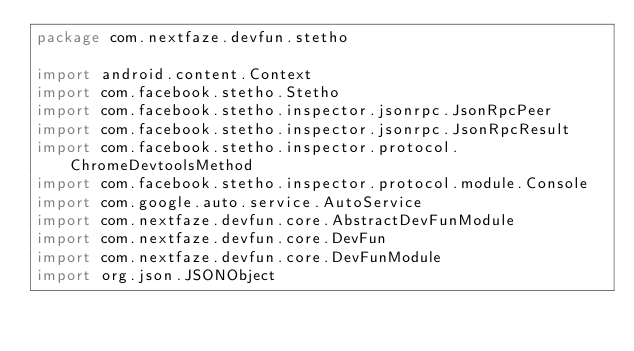Convert code to text. <code><loc_0><loc_0><loc_500><loc_500><_Kotlin_>package com.nextfaze.devfun.stetho

import android.content.Context
import com.facebook.stetho.Stetho
import com.facebook.stetho.inspector.jsonrpc.JsonRpcPeer
import com.facebook.stetho.inspector.jsonrpc.JsonRpcResult
import com.facebook.stetho.inspector.protocol.ChromeDevtoolsMethod
import com.facebook.stetho.inspector.protocol.module.Console
import com.google.auto.service.AutoService
import com.nextfaze.devfun.core.AbstractDevFunModule
import com.nextfaze.devfun.core.DevFun
import com.nextfaze.devfun.core.DevFunModule
import org.json.JSONObject</code> 